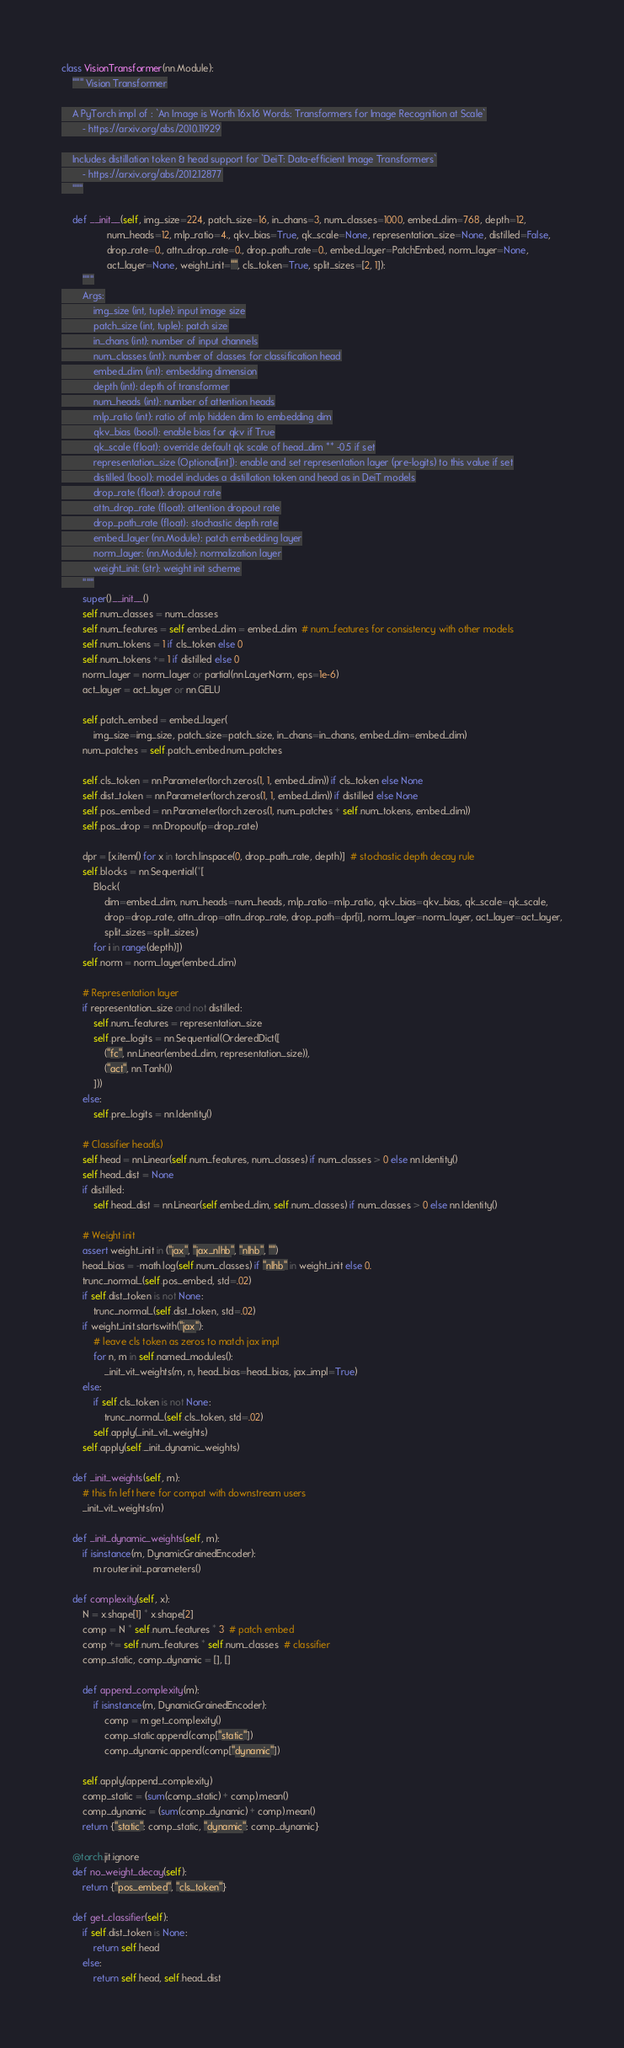<code> <loc_0><loc_0><loc_500><loc_500><_Python_>class VisionTransformer(nn.Module):
    """ Vision Transformer

    A PyTorch impl of : `An Image is Worth 16x16 Words: Transformers for Image Recognition at Scale`
        - https://arxiv.org/abs/2010.11929

    Includes distillation token & head support for `DeiT: Data-efficient Image Transformers`
        - https://arxiv.org/abs/2012.12877
    """

    def __init__(self, img_size=224, patch_size=16, in_chans=3, num_classes=1000, embed_dim=768, depth=12,
                 num_heads=12, mlp_ratio=4., qkv_bias=True, qk_scale=None, representation_size=None, distilled=False,
                 drop_rate=0., attn_drop_rate=0., drop_path_rate=0., embed_layer=PatchEmbed, norm_layer=None,
                 act_layer=None, weight_init="", cls_token=True, split_sizes=[2, 1]):
        """
        Args:
            img_size (int, tuple): input image size
            patch_size (int, tuple): patch size
            in_chans (int): number of input channels
            num_classes (int): number of classes for classification head
            embed_dim (int): embedding dimension
            depth (int): depth of transformer
            num_heads (int): number of attention heads
            mlp_ratio (int): ratio of mlp hidden dim to embedding dim
            qkv_bias (bool): enable bias for qkv if True
            qk_scale (float): override default qk scale of head_dim ** -0.5 if set
            representation_size (Optional[int]): enable and set representation layer (pre-logits) to this value if set
            distilled (bool): model includes a distillation token and head as in DeiT models
            drop_rate (float): dropout rate
            attn_drop_rate (float): attention dropout rate
            drop_path_rate (float): stochastic depth rate
            embed_layer (nn.Module): patch embedding layer
            norm_layer: (nn.Module): normalization layer
            weight_init: (str): weight init scheme
        """
        super().__init__()
        self.num_classes = num_classes
        self.num_features = self.embed_dim = embed_dim  # num_features for consistency with other models
        self.num_tokens = 1 if cls_token else 0
        self.num_tokens += 1 if distilled else 0
        norm_layer = norm_layer or partial(nn.LayerNorm, eps=1e-6)
        act_layer = act_layer or nn.GELU

        self.patch_embed = embed_layer(
            img_size=img_size, patch_size=patch_size, in_chans=in_chans, embed_dim=embed_dim)
        num_patches = self.patch_embed.num_patches

        self.cls_token = nn.Parameter(torch.zeros(1, 1, embed_dim)) if cls_token else None
        self.dist_token = nn.Parameter(torch.zeros(1, 1, embed_dim)) if distilled else None
        self.pos_embed = nn.Parameter(torch.zeros(1, num_patches + self.num_tokens, embed_dim))
        self.pos_drop = nn.Dropout(p=drop_rate)

        dpr = [x.item() for x in torch.linspace(0, drop_path_rate, depth)]  # stochastic depth decay rule
        self.blocks = nn.Sequential(*[
            Block(
                dim=embed_dim, num_heads=num_heads, mlp_ratio=mlp_ratio, qkv_bias=qkv_bias, qk_scale=qk_scale,
                drop=drop_rate, attn_drop=attn_drop_rate, drop_path=dpr[i], norm_layer=norm_layer, act_layer=act_layer,
                split_sizes=split_sizes)
            for i in range(depth)])
        self.norm = norm_layer(embed_dim)

        # Representation layer
        if representation_size and not distilled:
            self.num_features = representation_size
            self.pre_logits = nn.Sequential(OrderedDict([
                ("fc", nn.Linear(embed_dim, representation_size)),
                ("act", nn.Tanh())
            ]))
        else:
            self.pre_logits = nn.Identity()

        # Classifier head(s)
        self.head = nn.Linear(self.num_features, num_classes) if num_classes > 0 else nn.Identity()
        self.head_dist = None
        if distilled:
            self.head_dist = nn.Linear(self.embed_dim, self.num_classes) if num_classes > 0 else nn.Identity()

        # Weight init
        assert weight_init in ("jax", "jax_nlhb", "nlhb", "")
        head_bias = -math.log(self.num_classes) if "nlhb" in weight_init else 0.
        trunc_normal_(self.pos_embed, std=.02)
        if self.dist_token is not None:
            trunc_normal_(self.dist_token, std=.02)
        if weight_init.startswith("jax"):
            # leave cls token as zeros to match jax impl
            for n, m in self.named_modules():
                _init_vit_weights(m, n, head_bias=head_bias, jax_impl=True)
        else:
            if self.cls_token is not None:
                trunc_normal_(self.cls_token, std=.02)
            self.apply(_init_vit_weights)
        self.apply(self._init_dynamic_weights)

    def _init_weights(self, m):
        # this fn left here for compat with downstream users
        _init_vit_weights(m)

    def _init_dynamic_weights(self, m):
        if isinstance(m, DynamicGrainedEncoder):
            m.router.init_parameters()

    def complexity(self, x):
        N = x.shape[1] * x.shape[2]
        comp = N * self.num_features * 3  # patch embed
        comp += self.num_features * self.num_classes  # classifier
        comp_static, comp_dynamic = [], []

        def append_complexity(m):
            if isinstance(m, DynamicGrainedEncoder):
                comp = m.get_complexity()
                comp_static.append(comp["static"])
                comp_dynamic.append(comp["dynamic"])

        self.apply(append_complexity)
        comp_static = (sum(comp_static) + comp).mean()
        comp_dynamic = (sum(comp_dynamic) + comp).mean()
        return {"static": comp_static, "dynamic": comp_dynamic}

    @torch.jit.ignore
    def no_weight_decay(self):
        return {"pos_embed", "cls_token"}

    def get_classifier(self):
        if self.dist_token is None:
            return self.head
        else:
            return self.head, self.head_dist
</code> 